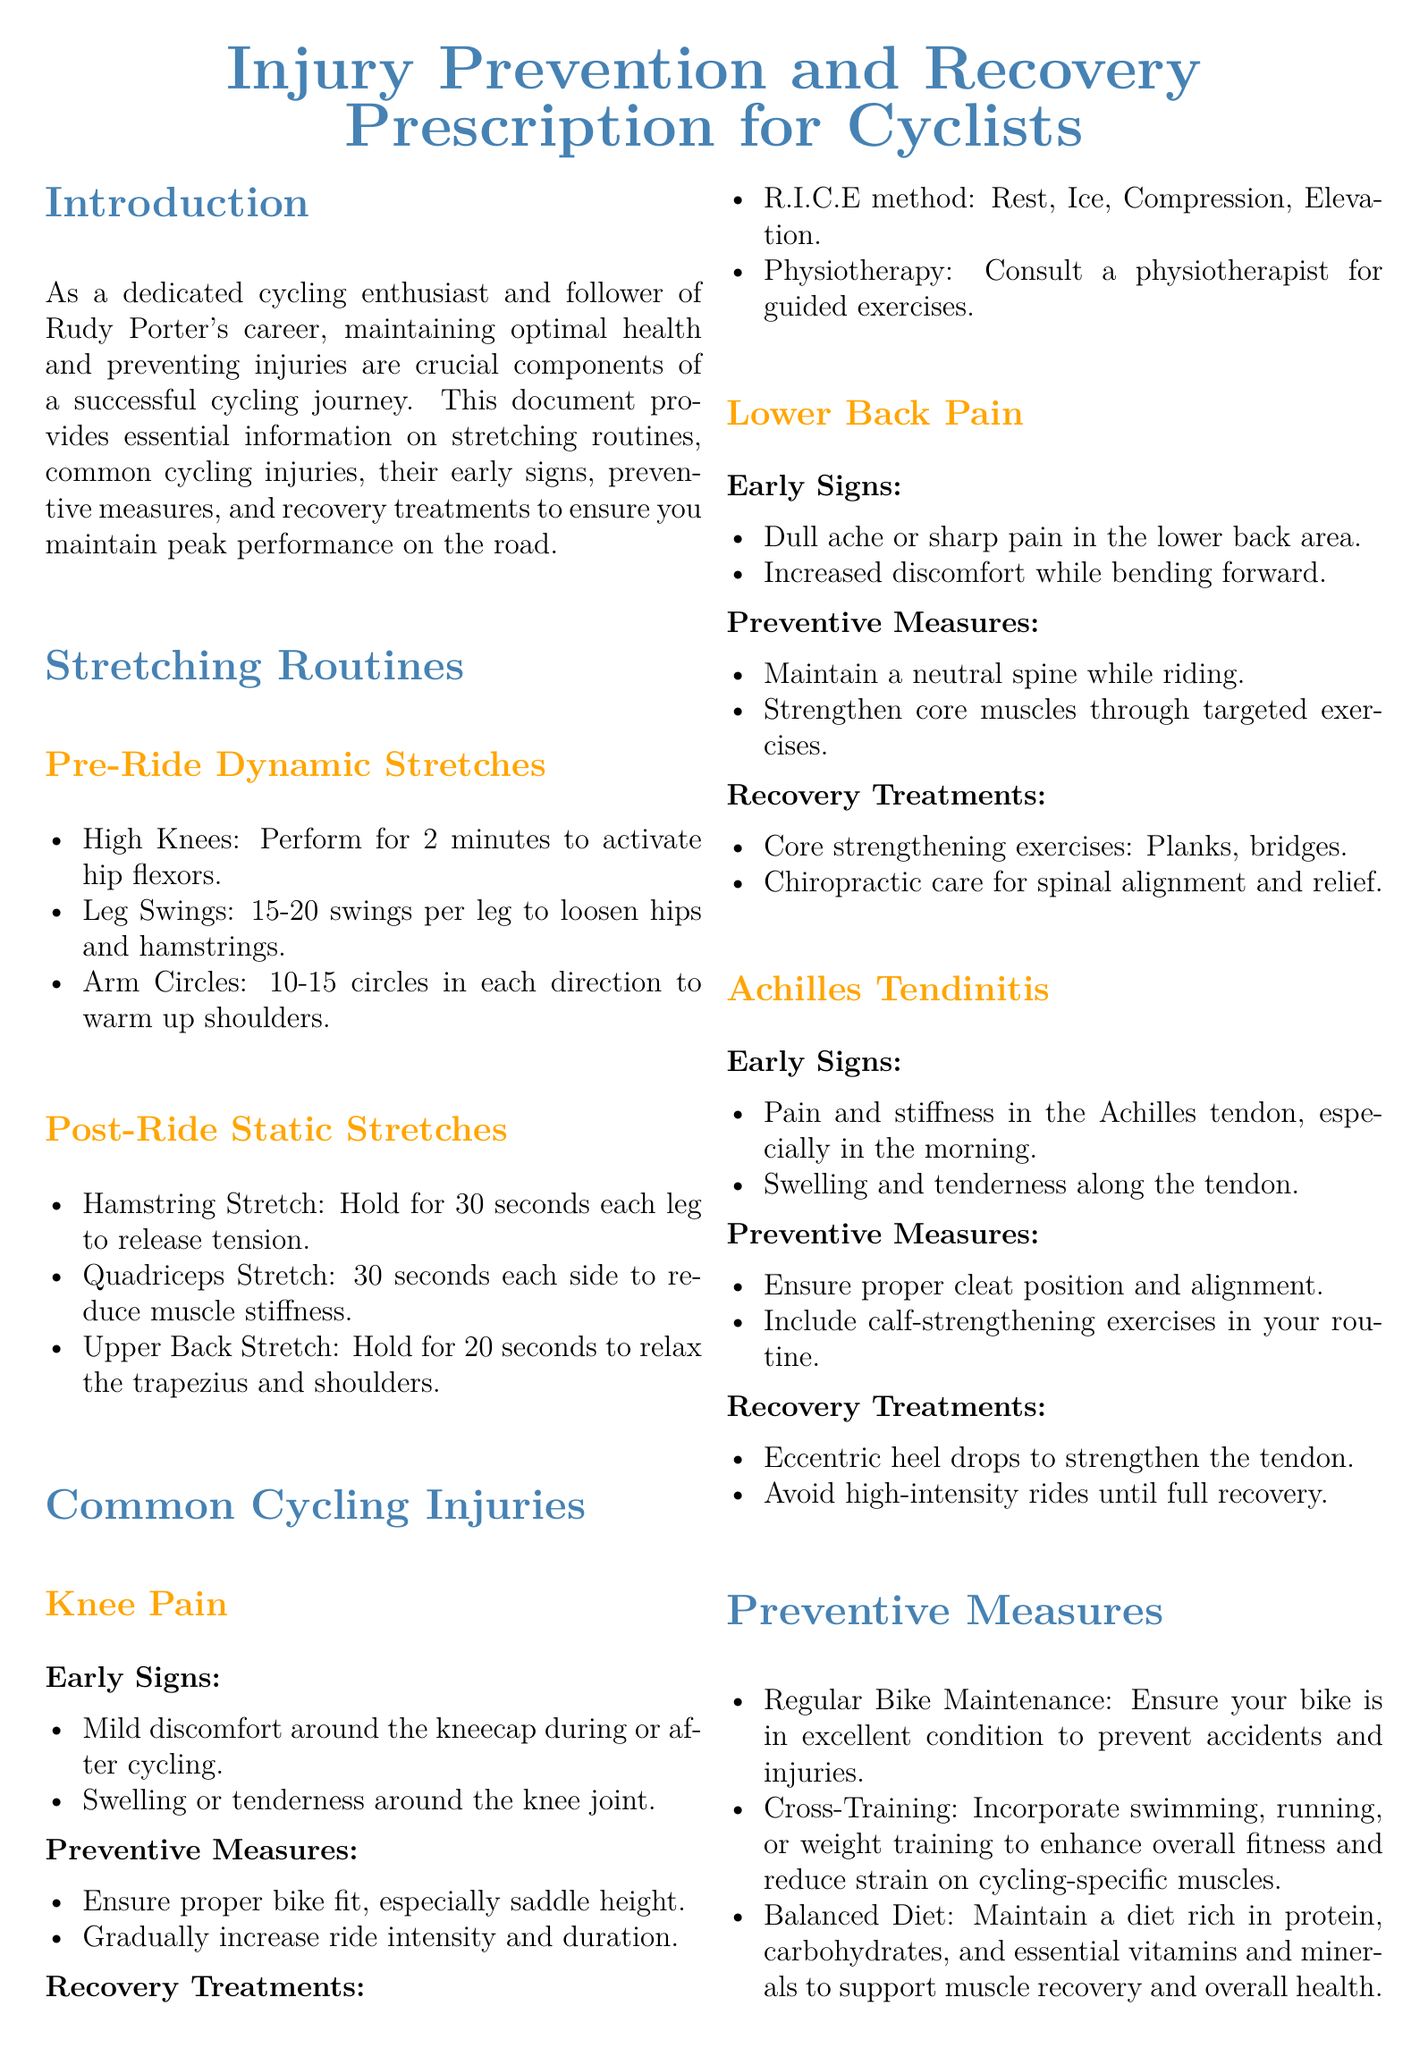What are the three pre-ride dynamic stretches? The three pre-ride dynamic stretches listed are High Knees, Leg Swings, and Arm Circles.
Answer: High Knees, Leg Swings, Arm Circles What is the recovery treatment for knee pain? Recovery treatments for knee pain include the R.I.C.E method and physiotherapy.
Answer: R.I.C.E method, physiotherapy What should cyclists maintain a balanced diet rich in? Cyclists should maintain a balanced diet rich in protein, carbohydrates, and essential vitamins and minerals.
Answer: Protein, carbohydrates, vitamins, minerals What type of pain is associated with Achilles tendinitis? Achilles tendinitis is associated with pain and stiffness in the Achilles tendon.
Answer: Pain and stiffness in the Achilles tendon What is a preventive measure for lower back pain? A preventive measure for lower back pain is to maintain a neutral spine while riding.
Answer: Neutral spine while riding How long should the hamstring stretch be held? The hamstring stretch should be held for 30 seconds each leg.
Answer: 30 seconds each leg How much sleep should cyclists prioritize per night for recovery? Cyclists should prioritize 7-9 hours of sleep per night for recovery.
Answer: 7-9 hours What is one common early sign of knee pain? One early sign of knee pain is mild discomfort around the kneecap during or after cycling.
Answer: Mild discomfort around the kneecap What exercise can help strengthen the Achilles tendon? Eccentric heel drops can help strengthen the Achilles tendon.
Answer: Eccentric heel drops 